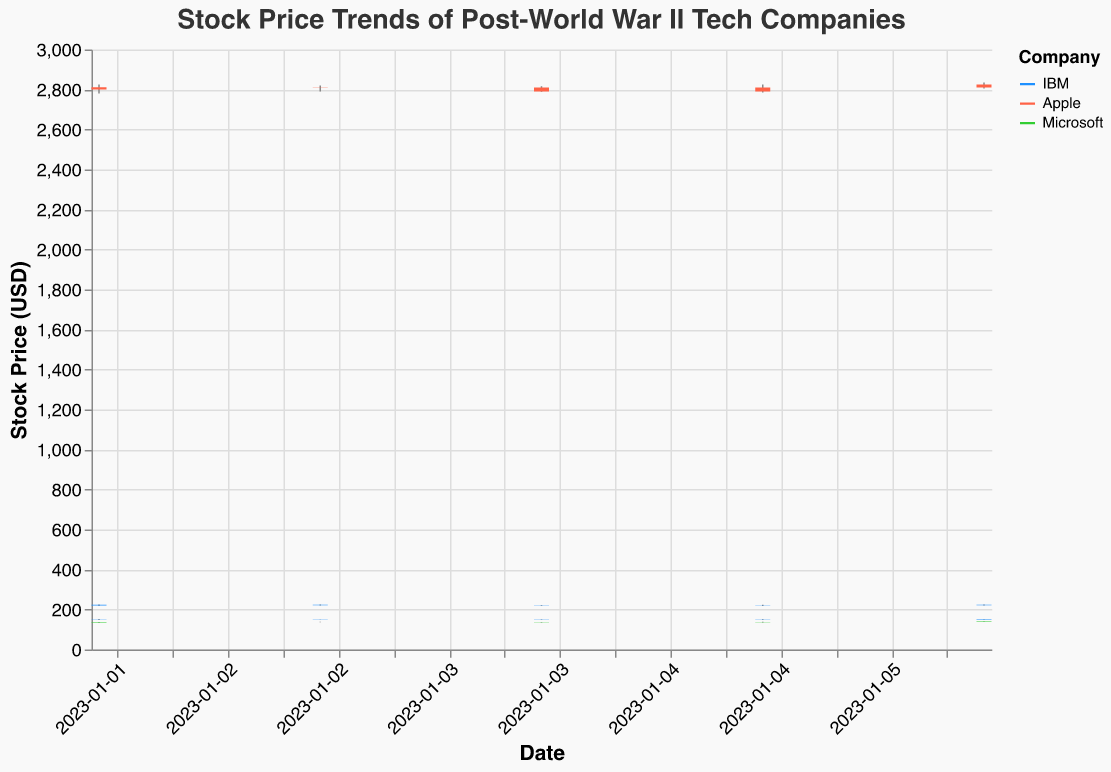What is the highest closing price for IBM from the given data? Check the 'Close' prices for IBM and find the highest value. The highest closing price for IBM is 152.00 on January 6, 2023.
Answer: 152.00 Which company has the lowest opening price on January 2, 2023? Compare the 'Open' prices on January 2, 2023, for IBM, Apple, and Microsoft. Microsoft has the lowest opening price of 135.00 on this date.
Answer: Microsoft Out of Apple and Microsoft, which company had a greater volume of traded shares on January 5, 2023? Compare the 'Volume' values on January 5, 2023, for Apple and Microsoft. Apple has a volume of 3300000, and Microsoft has 2300000. Therefore, Apple had a greater volume.
Answer: Apple By how much did IBM's closing price increase from January 3, 2023, to January 6, 2023? Compute the difference between IBM's closing prices on these dates: 152.00 (January 6) - 150.00 (January 3) = 2.00. IBM's closing price increased by 2.00.
Answer: 2.00 What is the stock price range (difference between the highest and lowest prices) for Microsoft on January 6, 2023? Calculate the range by subtracting the lowest price from the highest price for Microsoft on January 6, 2023: 140.00 - 137.50 = 2.50. The range is 2.50.
Answer: 2.50 Which company had the smallest change between its highest and lowest prices on January 3, 2023? Calculate the difference between 'High' and 'Low' prices for each company on January 3, 2023: IBM (151.00 - 149.50 = 1.50), Apple (2820.00 - 2790.50 = 29.50), Microsoft (138.50 - 136.00 = 2.50). IBM had the smallest change of 1.50.
Answer: IBM What was Apple's average closing price over the period January 2, 2023, to January 6, 2023? Compute the average of Apple's closing prices: (2810.75 + 2810.00 + 2790.00 + 2810.00 + 2825.00) / 5 = 2810.35. The average closing price is approximately 2810.35.
Answer: 2810.35 Did any company have a higher closing price on January 4, 2023, than their opening price on January 2, 2023? Compare the closing prices on January 4 with the opening prices on January 2 for IBM, Apple, and Microsoft. None of the companies had a higher closing price on January 4 than their opening price on January 2.
Answer: No What is the total volume of shares traded by all companies on January 5, 2023? Sum the 'Volume' values for all companies on January 5, 2023: 1300000 (IBM) + 3300000 (Apple) + 2300000 (Microsoft) + 1900000 (IBM from additional data) = 8800000. The total volume is 8800000.
Answer: 8800000 